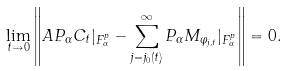Convert formula to latex. <formula><loc_0><loc_0><loc_500><loc_500>\lim _ { t \to 0 } \left \| A P _ { \alpha } C _ { t } | _ { F _ { \alpha } ^ { p } } - \sum _ { j = j _ { 0 } ( t ) } ^ { \infty } P _ { \alpha } M _ { \varphi _ { j , t } } | _ { F _ { \alpha } ^ { p } } \right \| = 0 .</formula> 